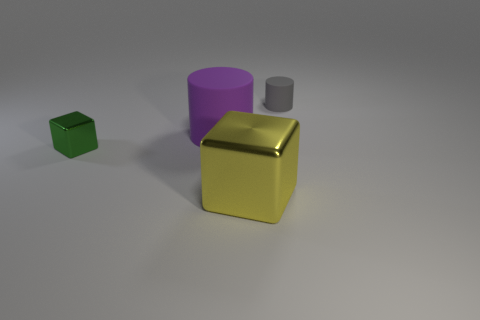Add 4 cyan matte balls. How many objects exist? 8 Add 3 small cylinders. How many small cylinders are left? 4 Add 2 green metal cubes. How many green metal cubes exist? 3 Subtract 0 gray cubes. How many objects are left? 4 Subtract all big red matte cylinders. Subtract all gray matte cylinders. How many objects are left? 3 